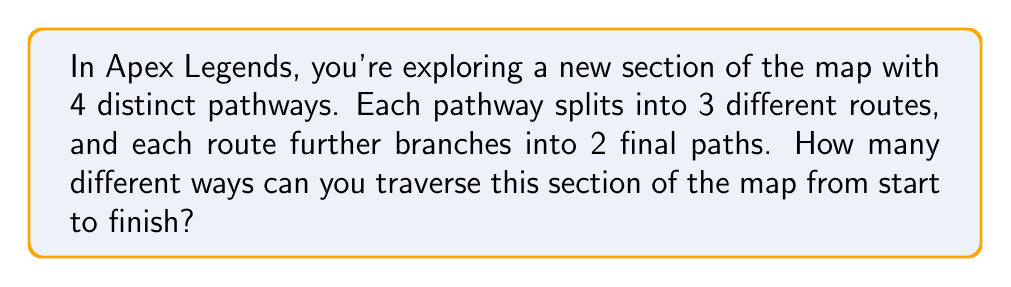Give your solution to this math problem. Let's break this down step-by-step:

1) We can think of this as a series of choices:
   - First, we choose 1 of the 4 initial pathways
   - Then, we choose 1 of the 3 routes within that pathway
   - Finally, we choose 1 of the 2 final paths

2) This is a perfect scenario for applying the multiplication principle of counting. When we have a series of independent choices, we multiply the number of options for each choice.

3) Let's set up our calculation:
   $$\text{Total number of ways} = \text{(Initial pathways)} \times \text{(Routes per pathway)} \times \text{(Final paths per route)}$$

4) Plugging in our numbers:
   $$\text{Total number of ways} = 4 \times 3 \times 2$$

5) Calculating:
   $$\text{Total number of ways} = 24$$

Therefore, there are 24 different ways to traverse this section of the map from start to finish.
Answer: 24 